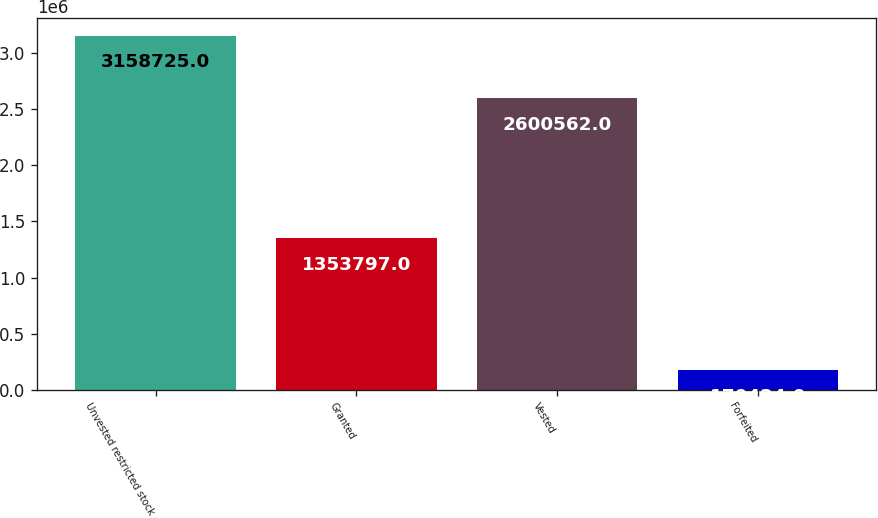Convert chart to OTSL. <chart><loc_0><loc_0><loc_500><loc_500><bar_chart><fcel>Unvested restricted stock<fcel>Granted<fcel>Vested<fcel>Forfeited<nl><fcel>3.15872e+06<fcel>1.3538e+06<fcel>2.60056e+06<fcel>170424<nl></chart> 